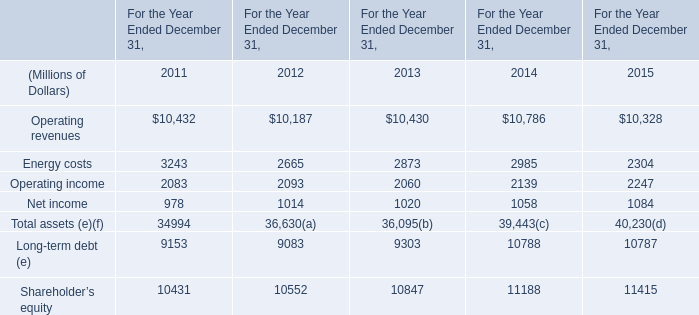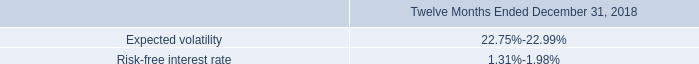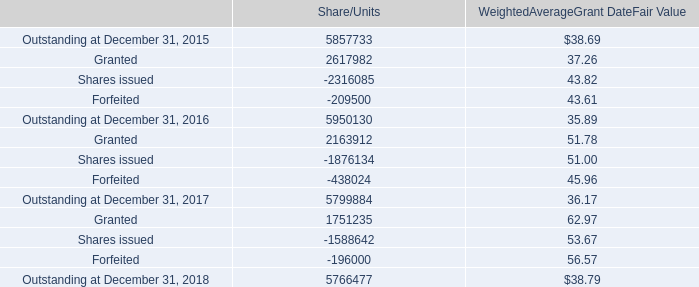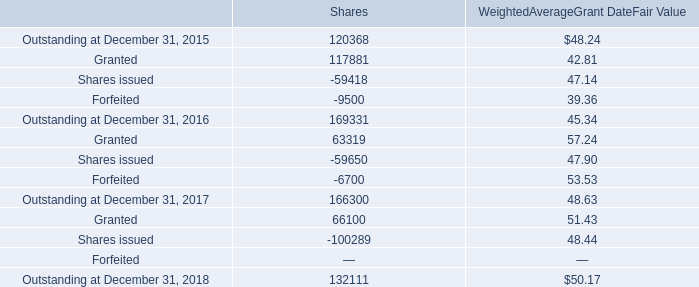What is the sum of Operating revenues in 2011? (in million) 
Answer: 10432. 